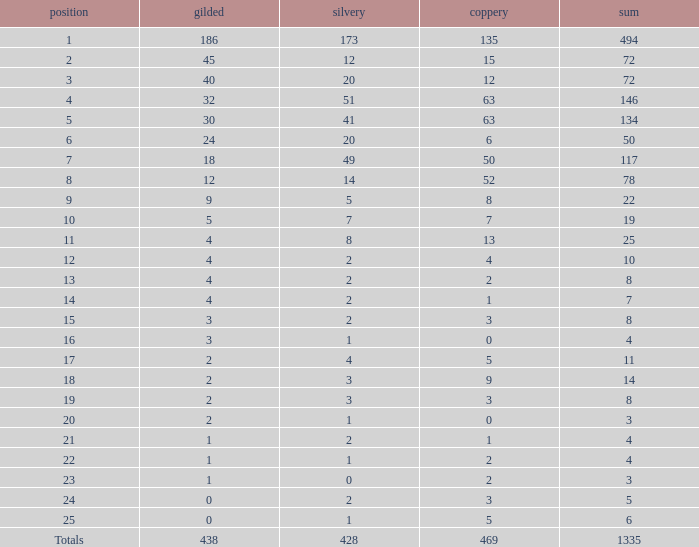Can you parse all the data within this table? {'header': ['position', 'gilded', 'silvery', 'coppery', 'sum'], 'rows': [['1', '186', '173', '135', '494'], ['2', '45', '12', '15', '72'], ['3', '40', '20', '12', '72'], ['4', '32', '51', '63', '146'], ['5', '30', '41', '63', '134'], ['6', '24', '20', '6', '50'], ['7', '18', '49', '50', '117'], ['8', '12', '14', '52', '78'], ['9', '9', '5', '8', '22'], ['10', '5', '7', '7', '19'], ['11', '4', '8', '13', '25'], ['12', '4', '2', '4', '10'], ['13', '4', '2', '2', '8'], ['14', '4', '2', '1', '7'], ['15', '3', '2', '3', '8'], ['16', '3', '1', '0', '4'], ['17', '2', '4', '5', '11'], ['18', '2', '3', '9', '14'], ['19', '2', '3', '3', '8'], ['20', '2', '1', '0', '3'], ['21', '1', '2', '1', '4'], ['22', '1', '1', '2', '4'], ['23', '1', '0', '2', '3'], ['24', '0', '2', '3', '5'], ['25', '0', '1', '5', '6'], ['Totals', '438', '428', '469', '1335']]} What is the average number of gold medals when the total was 1335 medals, with more than 469 bronzes and more than 14 silvers? None. 